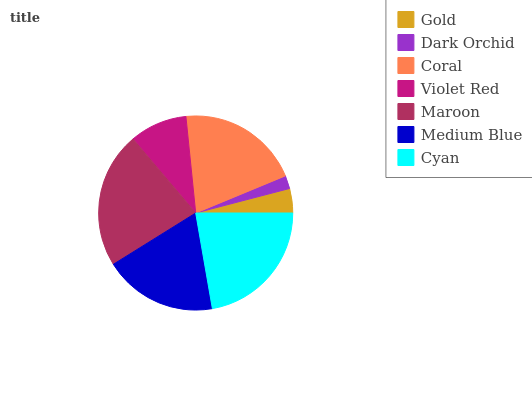Is Dark Orchid the minimum?
Answer yes or no. Yes. Is Maroon the maximum?
Answer yes or no. Yes. Is Coral the minimum?
Answer yes or no. No. Is Coral the maximum?
Answer yes or no. No. Is Coral greater than Dark Orchid?
Answer yes or no. Yes. Is Dark Orchid less than Coral?
Answer yes or no. Yes. Is Dark Orchid greater than Coral?
Answer yes or no. No. Is Coral less than Dark Orchid?
Answer yes or no. No. Is Medium Blue the high median?
Answer yes or no. Yes. Is Medium Blue the low median?
Answer yes or no. Yes. Is Violet Red the high median?
Answer yes or no. No. Is Coral the low median?
Answer yes or no. No. 